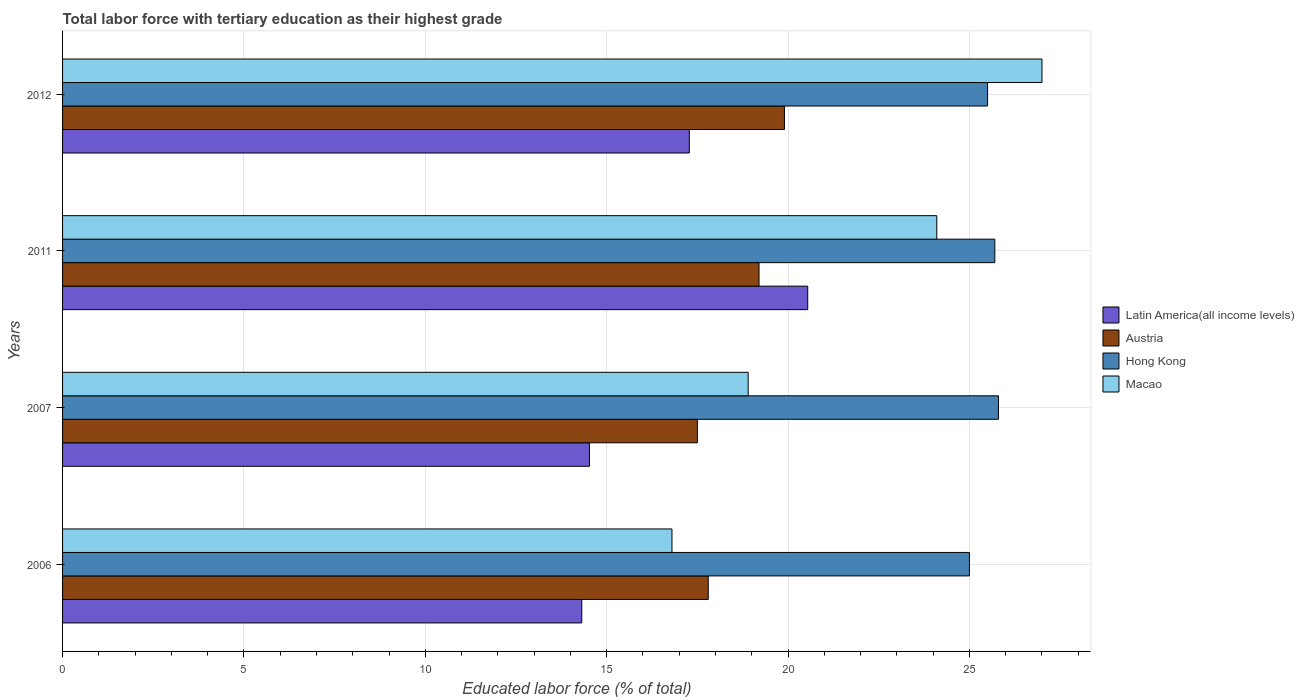Are the number of bars per tick equal to the number of legend labels?
Offer a very short reply. Yes. How many bars are there on the 3rd tick from the top?
Keep it short and to the point. 4. What is the label of the 2nd group of bars from the top?
Your response must be concise. 2011. What is the percentage of male labor force with tertiary education in Hong Kong in 2012?
Your response must be concise. 25.5. In which year was the percentage of male labor force with tertiary education in Austria maximum?
Provide a succinct answer. 2012. In which year was the percentage of male labor force with tertiary education in Macao minimum?
Your answer should be very brief. 2006. What is the total percentage of male labor force with tertiary education in Latin America(all income levels) in the graph?
Keep it short and to the point. 66.66. What is the difference between the percentage of male labor force with tertiary education in Latin America(all income levels) in 2006 and that in 2007?
Your response must be concise. -0.21. What is the difference between the percentage of male labor force with tertiary education in Macao in 2006 and the percentage of male labor force with tertiary education in Hong Kong in 2012?
Your answer should be very brief. -8.7. In the year 2006, what is the difference between the percentage of male labor force with tertiary education in Latin America(all income levels) and percentage of male labor force with tertiary education in Macao?
Ensure brevity in your answer.  -2.49. In how many years, is the percentage of male labor force with tertiary education in Macao greater than 14 %?
Provide a succinct answer. 4. What is the ratio of the percentage of male labor force with tertiary education in Latin America(all income levels) in 2007 to that in 2012?
Offer a very short reply. 0.84. Is the percentage of male labor force with tertiary education in Latin America(all income levels) in 2006 less than that in 2012?
Make the answer very short. Yes. What is the difference between the highest and the second highest percentage of male labor force with tertiary education in Latin America(all income levels)?
Ensure brevity in your answer.  3.26. What is the difference between the highest and the lowest percentage of male labor force with tertiary education in Latin America(all income levels)?
Make the answer very short. 6.23. In how many years, is the percentage of male labor force with tertiary education in Latin America(all income levels) greater than the average percentage of male labor force with tertiary education in Latin America(all income levels) taken over all years?
Ensure brevity in your answer.  2. Is the sum of the percentage of male labor force with tertiary education in Macao in 2006 and 2011 greater than the maximum percentage of male labor force with tertiary education in Austria across all years?
Provide a short and direct response. Yes. What does the 2nd bar from the top in 2012 represents?
Offer a very short reply. Hong Kong. What does the 3rd bar from the bottom in 2006 represents?
Your answer should be compact. Hong Kong. How many years are there in the graph?
Offer a terse response. 4. Does the graph contain grids?
Offer a terse response. Yes. How many legend labels are there?
Give a very brief answer. 4. How are the legend labels stacked?
Your response must be concise. Vertical. What is the title of the graph?
Make the answer very short. Total labor force with tertiary education as their highest grade. What is the label or title of the X-axis?
Offer a very short reply. Educated labor force (% of total). What is the label or title of the Y-axis?
Offer a terse response. Years. What is the Educated labor force (% of total) in Latin America(all income levels) in 2006?
Provide a succinct answer. 14.31. What is the Educated labor force (% of total) of Austria in 2006?
Your response must be concise. 17.8. What is the Educated labor force (% of total) of Hong Kong in 2006?
Make the answer very short. 25. What is the Educated labor force (% of total) in Macao in 2006?
Your answer should be very brief. 16.8. What is the Educated labor force (% of total) in Latin America(all income levels) in 2007?
Offer a terse response. 14.52. What is the Educated labor force (% of total) in Hong Kong in 2007?
Offer a very short reply. 25.8. What is the Educated labor force (% of total) in Macao in 2007?
Ensure brevity in your answer.  18.9. What is the Educated labor force (% of total) in Latin America(all income levels) in 2011?
Make the answer very short. 20.54. What is the Educated labor force (% of total) in Austria in 2011?
Your answer should be very brief. 19.2. What is the Educated labor force (% of total) of Hong Kong in 2011?
Keep it short and to the point. 25.7. What is the Educated labor force (% of total) in Macao in 2011?
Offer a terse response. 24.1. What is the Educated labor force (% of total) in Latin America(all income levels) in 2012?
Your response must be concise. 17.28. What is the Educated labor force (% of total) in Austria in 2012?
Keep it short and to the point. 19.9. What is the Educated labor force (% of total) of Macao in 2012?
Offer a terse response. 27. Across all years, what is the maximum Educated labor force (% of total) of Latin America(all income levels)?
Your answer should be very brief. 20.54. Across all years, what is the maximum Educated labor force (% of total) of Austria?
Ensure brevity in your answer.  19.9. Across all years, what is the maximum Educated labor force (% of total) of Hong Kong?
Ensure brevity in your answer.  25.8. Across all years, what is the maximum Educated labor force (% of total) in Macao?
Your answer should be very brief. 27. Across all years, what is the minimum Educated labor force (% of total) in Latin America(all income levels)?
Your response must be concise. 14.31. Across all years, what is the minimum Educated labor force (% of total) of Austria?
Offer a very short reply. 17.5. Across all years, what is the minimum Educated labor force (% of total) of Hong Kong?
Your response must be concise. 25. Across all years, what is the minimum Educated labor force (% of total) of Macao?
Provide a succinct answer. 16.8. What is the total Educated labor force (% of total) in Latin America(all income levels) in the graph?
Your answer should be very brief. 66.66. What is the total Educated labor force (% of total) of Austria in the graph?
Give a very brief answer. 74.4. What is the total Educated labor force (% of total) of Hong Kong in the graph?
Give a very brief answer. 102. What is the total Educated labor force (% of total) of Macao in the graph?
Ensure brevity in your answer.  86.8. What is the difference between the Educated labor force (% of total) in Latin America(all income levels) in 2006 and that in 2007?
Make the answer very short. -0.21. What is the difference between the Educated labor force (% of total) of Hong Kong in 2006 and that in 2007?
Make the answer very short. -0.8. What is the difference between the Educated labor force (% of total) of Latin America(all income levels) in 2006 and that in 2011?
Provide a succinct answer. -6.23. What is the difference between the Educated labor force (% of total) of Hong Kong in 2006 and that in 2011?
Give a very brief answer. -0.7. What is the difference between the Educated labor force (% of total) of Latin America(all income levels) in 2006 and that in 2012?
Give a very brief answer. -2.96. What is the difference between the Educated labor force (% of total) of Austria in 2006 and that in 2012?
Your answer should be compact. -2.1. What is the difference between the Educated labor force (% of total) in Hong Kong in 2006 and that in 2012?
Offer a very short reply. -0.5. What is the difference between the Educated labor force (% of total) of Latin America(all income levels) in 2007 and that in 2011?
Your response must be concise. -6.02. What is the difference between the Educated labor force (% of total) of Latin America(all income levels) in 2007 and that in 2012?
Keep it short and to the point. -2.75. What is the difference between the Educated labor force (% of total) of Hong Kong in 2007 and that in 2012?
Provide a short and direct response. 0.3. What is the difference between the Educated labor force (% of total) of Macao in 2007 and that in 2012?
Give a very brief answer. -8.1. What is the difference between the Educated labor force (% of total) in Latin America(all income levels) in 2011 and that in 2012?
Offer a terse response. 3.26. What is the difference between the Educated labor force (% of total) of Austria in 2011 and that in 2012?
Provide a succinct answer. -0.7. What is the difference between the Educated labor force (% of total) of Hong Kong in 2011 and that in 2012?
Provide a short and direct response. 0.2. What is the difference between the Educated labor force (% of total) of Latin America(all income levels) in 2006 and the Educated labor force (% of total) of Austria in 2007?
Offer a very short reply. -3.19. What is the difference between the Educated labor force (% of total) in Latin America(all income levels) in 2006 and the Educated labor force (% of total) in Hong Kong in 2007?
Your answer should be compact. -11.49. What is the difference between the Educated labor force (% of total) in Latin America(all income levels) in 2006 and the Educated labor force (% of total) in Macao in 2007?
Your answer should be compact. -4.59. What is the difference between the Educated labor force (% of total) in Austria in 2006 and the Educated labor force (% of total) in Macao in 2007?
Your answer should be compact. -1.1. What is the difference between the Educated labor force (% of total) in Hong Kong in 2006 and the Educated labor force (% of total) in Macao in 2007?
Offer a terse response. 6.1. What is the difference between the Educated labor force (% of total) of Latin America(all income levels) in 2006 and the Educated labor force (% of total) of Austria in 2011?
Your answer should be very brief. -4.89. What is the difference between the Educated labor force (% of total) in Latin America(all income levels) in 2006 and the Educated labor force (% of total) in Hong Kong in 2011?
Offer a terse response. -11.39. What is the difference between the Educated labor force (% of total) of Latin America(all income levels) in 2006 and the Educated labor force (% of total) of Macao in 2011?
Ensure brevity in your answer.  -9.79. What is the difference between the Educated labor force (% of total) in Austria in 2006 and the Educated labor force (% of total) in Hong Kong in 2011?
Offer a terse response. -7.9. What is the difference between the Educated labor force (% of total) of Austria in 2006 and the Educated labor force (% of total) of Macao in 2011?
Offer a very short reply. -6.3. What is the difference between the Educated labor force (% of total) of Latin America(all income levels) in 2006 and the Educated labor force (% of total) of Austria in 2012?
Give a very brief answer. -5.59. What is the difference between the Educated labor force (% of total) in Latin America(all income levels) in 2006 and the Educated labor force (% of total) in Hong Kong in 2012?
Keep it short and to the point. -11.19. What is the difference between the Educated labor force (% of total) of Latin America(all income levels) in 2006 and the Educated labor force (% of total) of Macao in 2012?
Provide a short and direct response. -12.69. What is the difference between the Educated labor force (% of total) of Austria in 2006 and the Educated labor force (% of total) of Hong Kong in 2012?
Give a very brief answer. -7.7. What is the difference between the Educated labor force (% of total) of Austria in 2006 and the Educated labor force (% of total) of Macao in 2012?
Your answer should be compact. -9.2. What is the difference between the Educated labor force (% of total) in Hong Kong in 2006 and the Educated labor force (% of total) in Macao in 2012?
Provide a succinct answer. -2. What is the difference between the Educated labor force (% of total) in Latin America(all income levels) in 2007 and the Educated labor force (% of total) in Austria in 2011?
Offer a very short reply. -4.68. What is the difference between the Educated labor force (% of total) in Latin America(all income levels) in 2007 and the Educated labor force (% of total) in Hong Kong in 2011?
Your answer should be compact. -11.18. What is the difference between the Educated labor force (% of total) in Latin America(all income levels) in 2007 and the Educated labor force (% of total) in Macao in 2011?
Ensure brevity in your answer.  -9.58. What is the difference between the Educated labor force (% of total) of Austria in 2007 and the Educated labor force (% of total) of Hong Kong in 2011?
Your response must be concise. -8.2. What is the difference between the Educated labor force (% of total) in Austria in 2007 and the Educated labor force (% of total) in Macao in 2011?
Your answer should be very brief. -6.6. What is the difference between the Educated labor force (% of total) of Latin America(all income levels) in 2007 and the Educated labor force (% of total) of Austria in 2012?
Your answer should be compact. -5.38. What is the difference between the Educated labor force (% of total) in Latin America(all income levels) in 2007 and the Educated labor force (% of total) in Hong Kong in 2012?
Your answer should be compact. -10.98. What is the difference between the Educated labor force (% of total) of Latin America(all income levels) in 2007 and the Educated labor force (% of total) of Macao in 2012?
Give a very brief answer. -12.48. What is the difference between the Educated labor force (% of total) of Austria in 2007 and the Educated labor force (% of total) of Hong Kong in 2012?
Your response must be concise. -8. What is the difference between the Educated labor force (% of total) in Austria in 2007 and the Educated labor force (% of total) in Macao in 2012?
Offer a very short reply. -9.5. What is the difference between the Educated labor force (% of total) of Latin America(all income levels) in 2011 and the Educated labor force (% of total) of Austria in 2012?
Your answer should be compact. 0.64. What is the difference between the Educated labor force (% of total) of Latin America(all income levels) in 2011 and the Educated labor force (% of total) of Hong Kong in 2012?
Offer a very short reply. -4.96. What is the difference between the Educated labor force (% of total) in Latin America(all income levels) in 2011 and the Educated labor force (% of total) in Macao in 2012?
Keep it short and to the point. -6.46. What is the difference between the Educated labor force (% of total) of Hong Kong in 2011 and the Educated labor force (% of total) of Macao in 2012?
Offer a terse response. -1.3. What is the average Educated labor force (% of total) in Latin America(all income levels) per year?
Provide a short and direct response. 16.66. What is the average Educated labor force (% of total) of Austria per year?
Offer a terse response. 18.6. What is the average Educated labor force (% of total) in Macao per year?
Your answer should be very brief. 21.7. In the year 2006, what is the difference between the Educated labor force (% of total) of Latin America(all income levels) and Educated labor force (% of total) of Austria?
Your response must be concise. -3.49. In the year 2006, what is the difference between the Educated labor force (% of total) in Latin America(all income levels) and Educated labor force (% of total) in Hong Kong?
Provide a short and direct response. -10.69. In the year 2006, what is the difference between the Educated labor force (% of total) of Latin America(all income levels) and Educated labor force (% of total) of Macao?
Keep it short and to the point. -2.49. In the year 2006, what is the difference between the Educated labor force (% of total) of Austria and Educated labor force (% of total) of Hong Kong?
Offer a terse response. -7.2. In the year 2007, what is the difference between the Educated labor force (% of total) in Latin America(all income levels) and Educated labor force (% of total) in Austria?
Provide a short and direct response. -2.98. In the year 2007, what is the difference between the Educated labor force (% of total) in Latin America(all income levels) and Educated labor force (% of total) in Hong Kong?
Your response must be concise. -11.28. In the year 2007, what is the difference between the Educated labor force (% of total) of Latin America(all income levels) and Educated labor force (% of total) of Macao?
Make the answer very short. -4.38. In the year 2007, what is the difference between the Educated labor force (% of total) in Austria and Educated labor force (% of total) in Hong Kong?
Provide a succinct answer. -8.3. In the year 2007, what is the difference between the Educated labor force (% of total) of Hong Kong and Educated labor force (% of total) of Macao?
Offer a terse response. 6.9. In the year 2011, what is the difference between the Educated labor force (% of total) of Latin America(all income levels) and Educated labor force (% of total) of Austria?
Offer a terse response. 1.34. In the year 2011, what is the difference between the Educated labor force (% of total) in Latin America(all income levels) and Educated labor force (% of total) in Hong Kong?
Ensure brevity in your answer.  -5.16. In the year 2011, what is the difference between the Educated labor force (% of total) in Latin America(all income levels) and Educated labor force (% of total) in Macao?
Make the answer very short. -3.56. In the year 2011, what is the difference between the Educated labor force (% of total) of Austria and Educated labor force (% of total) of Macao?
Keep it short and to the point. -4.9. In the year 2012, what is the difference between the Educated labor force (% of total) of Latin America(all income levels) and Educated labor force (% of total) of Austria?
Your response must be concise. -2.62. In the year 2012, what is the difference between the Educated labor force (% of total) in Latin America(all income levels) and Educated labor force (% of total) in Hong Kong?
Offer a terse response. -8.22. In the year 2012, what is the difference between the Educated labor force (% of total) in Latin America(all income levels) and Educated labor force (% of total) in Macao?
Your response must be concise. -9.72. What is the ratio of the Educated labor force (% of total) in Latin America(all income levels) in 2006 to that in 2007?
Offer a terse response. 0.99. What is the ratio of the Educated labor force (% of total) in Austria in 2006 to that in 2007?
Provide a short and direct response. 1.02. What is the ratio of the Educated labor force (% of total) of Macao in 2006 to that in 2007?
Keep it short and to the point. 0.89. What is the ratio of the Educated labor force (% of total) of Latin America(all income levels) in 2006 to that in 2011?
Keep it short and to the point. 0.7. What is the ratio of the Educated labor force (% of total) of Austria in 2006 to that in 2011?
Provide a short and direct response. 0.93. What is the ratio of the Educated labor force (% of total) of Hong Kong in 2006 to that in 2011?
Ensure brevity in your answer.  0.97. What is the ratio of the Educated labor force (% of total) of Macao in 2006 to that in 2011?
Your answer should be compact. 0.7. What is the ratio of the Educated labor force (% of total) in Latin America(all income levels) in 2006 to that in 2012?
Make the answer very short. 0.83. What is the ratio of the Educated labor force (% of total) of Austria in 2006 to that in 2012?
Keep it short and to the point. 0.89. What is the ratio of the Educated labor force (% of total) of Hong Kong in 2006 to that in 2012?
Offer a terse response. 0.98. What is the ratio of the Educated labor force (% of total) of Macao in 2006 to that in 2012?
Keep it short and to the point. 0.62. What is the ratio of the Educated labor force (% of total) in Latin America(all income levels) in 2007 to that in 2011?
Provide a succinct answer. 0.71. What is the ratio of the Educated labor force (% of total) of Austria in 2007 to that in 2011?
Ensure brevity in your answer.  0.91. What is the ratio of the Educated labor force (% of total) of Hong Kong in 2007 to that in 2011?
Keep it short and to the point. 1. What is the ratio of the Educated labor force (% of total) in Macao in 2007 to that in 2011?
Your response must be concise. 0.78. What is the ratio of the Educated labor force (% of total) of Latin America(all income levels) in 2007 to that in 2012?
Give a very brief answer. 0.84. What is the ratio of the Educated labor force (% of total) of Austria in 2007 to that in 2012?
Provide a short and direct response. 0.88. What is the ratio of the Educated labor force (% of total) of Hong Kong in 2007 to that in 2012?
Your response must be concise. 1.01. What is the ratio of the Educated labor force (% of total) in Macao in 2007 to that in 2012?
Provide a short and direct response. 0.7. What is the ratio of the Educated labor force (% of total) in Latin America(all income levels) in 2011 to that in 2012?
Give a very brief answer. 1.19. What is the ratio of the Educated labor force (% of total) in Austria in 2011 to that in 2012?
Your response must be concise. 0.96. What is the ratio of the Educated labor force (% of total) of Hong Kong in 2011 to that in 2012?
Offer a very short reply. 1.01. What is the ratio of the Educated labor force (% of total) of Macao in 2011 to that in 2012?
Provide a short and direct response. 0.89. What is the difference between the highest and the second highest Educated labor force (% of total) in Latin America(all income levels)?
Your answer should be compact. 3.26. What is the difference between the highest and the second highest Educated labor force (% of total) in Austria?
Your response must be concise. 0.7. What is the difference between the highest and the second highest Educated labor force (% of total) of Macao?
Provide a succinct answer. 2.9. What is the difference between the highest and the lowest Educated labor force (% of total) in Latin America(all income levels)?
Make the answer very short. 6.23. What is the difference between the highest and the lowest Educated labor force (% of total) of Austria?
Keep it short and to the point. 2.4. What is the difference between the highest and the lowest Educated labor force (% of total) in Hong Kong?
Keep it short and to the point. 0.8. What is the difference between the highest and the lowest Educated labor force (% of total) in Macao?
Your answer should be very brief. 10.2. 